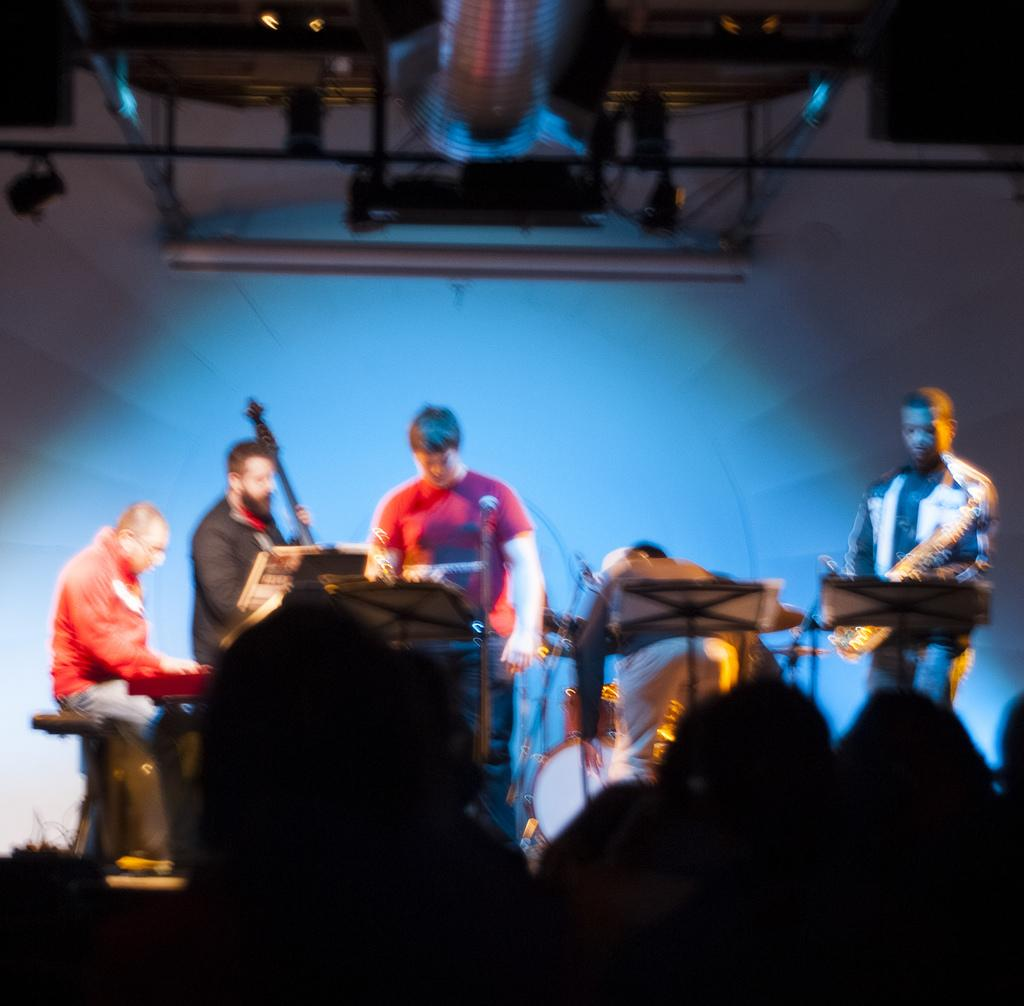What are the people on the stage doing in the image? The people on the stage are playing musical instruments. Can you identify any specific instruments being played? At least one person is playing a guitar. Who else is present in the image besides the musicians on stage? There are spectators watching the performance. What decision did the librarian make about the bomb in the image? There is no mention of a library, decision, or bomb in the image. The image features people playing musical instruments on a stage with spectators watching. 